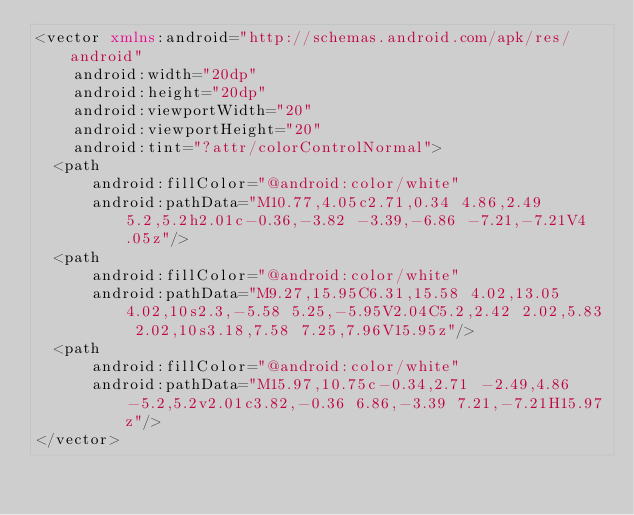<code> <loc_0><loc_0><loc_500><loc_500><_XML_><vector xmlns:android="http://schemas.android.com/apk/res/android"
    android:width="20dp"
    android:height="20dp"
    android:viewportWidth="20"
    android:viewportHeight="20"
    android:tint="?attr/colorControlNormal">
  <path
      android:fillColor="@android:color/white"
      android:pathData="M10.77,4.05c2.71,0.34 4.86,2.49 5.2,5.2h2.01c-0.36,-3.82 -3.39,-6.86 -7.21,-7.21V4.05z"/>
  <path
      android:fillColor="@android:color/white"
      android:pathData="M9.27,15.95C6.31,15.58 4.02,13.05 4.02,10s2.3,-5.58 5.25,-5.95V2.04C5.2,2.42 2.02,5.83 2.02,10s3.18,7.58 7.25,7.96V15.95z"/>
  <path
      android:fillColor="@android:color/white"
      android:pathData="M15.97,10.75c-0.34,2.71 -2.49,4.86 -5.2,5.2v2.01c3.82,-0.36 6.86,-3.39 7.21,-7.21H15.97z"/>
</vector>
</code> 